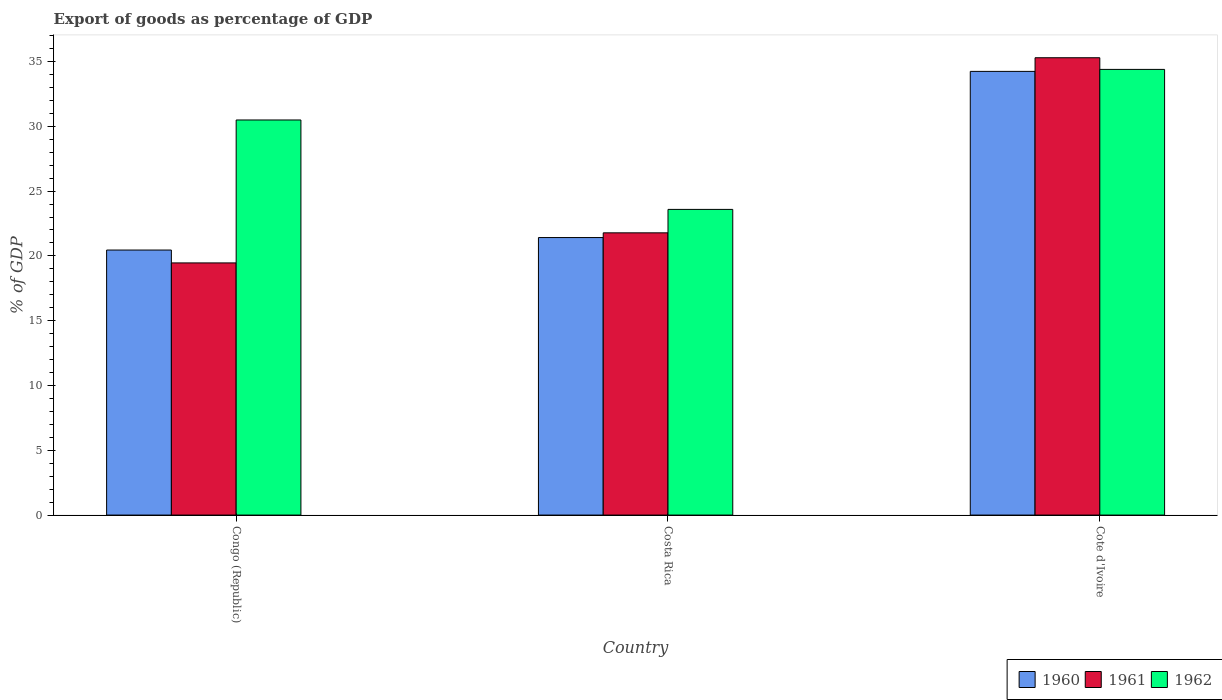How many different coloured bars are there?
Your answer should be very brief. 3. Are the number of bars per tick equal to the number of legend labels?
Offer a very short reply. Yes. How many bars are there on the 1st tick from the left?
Offer a very short reply. 3. How many bars are there on the 1st tick from the right?
Provide a short and direct response. 3. What is the label of the 2nd group of bars from the left?
Your answer should be compact. Costa Rica. What is the export of goods as percentage of GDP in 1961 in Cote d'Ivoire?
Provide a short and direct response. 35.29. Across all countries, what is the maximum export of goods as percentage of GDP in 1960?
Keep it short and to the point. 34.24. Across all countries, what is the minimum export of goods as percentage of GDP in 1961?
Offer a very short reply. 19.46. In which country was the export of goods as percentage of GDP in 1962 maximum?
Offer a terse response. Cote d'Ivoire. In which country was the export of goods as percentage of GDP in 1960 minimum?
Offer a terse response. Congo (Republic). What is the total export of goods as percentage of GDP in 1961 in the graph?
Make the answer very short. 76.53. What is the difference between the export of goods as percentage of GDP in 1961 in Congo (Republic) and that in Costa Rica?
Keep it short and to the point. -2.32. What is the difference between the export of goods as percentage of GDP in 1961 in Costa Rica and the export of goods as percentage of GDP in 1962 in Congo (Republic)?
Provide a short and direct response. -8.71. What is the average export of goods as percentage of GDP in 1961 per country?
Make the answer very short. 25.51. What is the difference between the export of goods as percentage of GDP of/in 1960 and export of goods as percentage of GDP of/in 1962 in Costa Rica?
Ensure brevity in your answer.  -2.17. What is the ratio of the export of goods as percentage of GDP in 1962 in Costa Rica to that in Cote d'Ivoire?
Your answer should be very brief. 0.69. What is the difference between the highest and the second highest export of goods as percentage of GDP in 1960?
Your answer should be very brief. 13.79. What is the difference between the highest and the lowest export of goods as percentage of GDP in 1960?
Offer a very short reply. 13.79. In how many countries, is the export of goods as percentage of GDP in 1961 greater than the average export of goods as percentage of GDP in 1961 taken over all countries?
Your response must be concise. 1. Is the sum of the export of goods as percentage of GDP in 1962 in Costa Rica and Cote d'Ivoire greater than the maximum export of goods as percentage of GDP in 1961 across all countries?
Provide a short and direct response. Yes. What does the 1st bar from the left in Cote d'Ivoire represents?
Give a very brief answer. 1960. What does the 2nd bar from the right in Costa Rica represents?
Provide a succinct answer. 1961. Are all the bars in the graph horizontal?
Offer a terse response. No. How many countries are there in the graph?
Your answer should be compact. 3. What is the difference between two consecutive major ticks on the Y-axis?
Your answer should be compact. 5. Are the values on the major ticks of Y-axis written in scientific E-notation?
Offer a very short reply. No. Does the graph contain any zero values?
Provide a short and direct response. No. Where does the legend appear in the graph?
Keep it short and to the point. Bottom right. What is the title of the graph?
Keep it short and to the point. Export of goods as percentage of GDP. Does "1966" appear as one of the legend labels in the graph?
Offer a very short reply. No. What is the label or title of the Y-axis?
Your answer should be very brief. % of GDP. What is the % of GDP of 1960 in Congo (Republic)?
Keep it short and to the point. 20.45. What is the % of GDP of 1961 in Congo (Republic)?
Give a very brief answer. 19.46. What is the % of GDP of 1962 in Congo (Republic)?
Ensure brevity in your answer.  30.49. What is the % of GDP of 1960 in Costa Rica?
Provide a short and direct response. 21.42. What is the % of GDP of 1961 in Costa Rica?
Ensure brevity in your answer.  21.78. What is the % of GDP in 1962 in Costa Rica?
Offer a very short reply. 23.59. What is the % of GDP in 1960 in Cote d'Ivoire?
Your response must be concise. 34.24. What is the % of GDP in 1961 in Cote d'Ivoire?
Your answer should be very brief. 35.29. What is the % of GDP of 1962 in Cote d'Ivoire?
Your answer should be compact. 34.39. Across all countries, what is the maximum % of GDP in 1960?
Keep it short and to the point. 34.24. Across all countries, what is the maximum % of GDP of 1961?
Offer a terse response. 35.29. Across all countries, what is the maximum % of GDP in 1962?
Your answer should be very brief. 34.39. Across all countries, what is the minimum % of GDP in 1960?
Your answer should be compact. 20.45. Across all countries, what is the minimum % of GDP of 1961?
Your answer should be very brief. 19.46. Across all countries, what is the minimum % of GDP of 1962?
Provide a short and direct response. 23.59. What is the total % of GDP in 1960 in the graph?
Give a very brief answer. 76.11. What is the total % of GDP of 1961 in the graph?
Your answer should be compact. 76.53. What is the total % of GDP in 1962 in the graph?
Offer a very short reply. 88.47. What is the difference between the % of GDP in 1960 in Congo (Republic) and that in Costa Rica?
Make the answer very short. -0.96. What is the difference between the % of GDP in 1961 in Congo (Republic) and that in Costa Rica?
Give a very brief answer. -2.32. What is the difference between the % of GDP in 1962 in Congo (Republic) and that in Costa Rica?
Offer a terse response. 6.9. What is the difference between the % of GDP in 1960 in Congo (Republic) and that in Cote d'Ivoire?
Your response must be concise. -13.79. What is the difference between the % of GDP in 1961 in Congo (Republic) and that in Cote d'Ivoire?
Your response must be concise. -15.83. What is the difference between the % of GDP in 1962 in Congo (Republic) and that in Cote d'Ivoire?
Give a very brief answer. -3.9. What is the difference between the % of GDP in 1960 in Costa Rica and that in Cote d'Ivoire?
Keep it short and to the point. -12.82. What is the difference between the % of GDP of 1961 in Costa Rica and that in Cote d'Ivoire?
Provide a succinct answer. -13.51. What is the difference between the % of GDP in 1962 in Costa Rica and that in Cote d'Ivoire?
Your answer should be very brief. -10.8. What is the difference between the % of GDP in 1960 in Congo (Republic) and the % of GDP in 1961 in Costa Rica?
Your answer should be very brief. -1.33. What is the difference between the % of GDP in 1960 in Congo (Republic) and the % of GDP in 1962 in Costa Rica?
Offer a terse response. -3.14. What is the difference between the % of GDP of 1961 in Congo (Republic) and the % of GDP of 1962 in Costa Rica?
Your response must be concise. -4.13. What is the difference between the % of GDP in 1960 in Congo (Republic) and the % of GDP in 1961 in Cote d'Ivoire?
Make the answer very short. -14.84. What is the difference between the % of GDP of 1960 in Congo (Republic) and the % of GDP of 1962 in Cote d'Ivoire?
Provide a succinct answer. -13.94. What is the difference between the % of GDP of 1961 in Congo (Republic) and the % of GDP of 1962 in Cote d'Ivoire?
Keep it short and to the point. -14.93. What is the difference between the % of GDP in 1960 in Costa Rica and the % of GDP in 1961 in Cote d'Ivoire?
Offer a terse response. -13.88. What is the difference between the % of GDP of 1960 in Costa Rica and the % of GDP of 1962 in Cote d'Ivoire?
Your response must be concise. -12.98. What is the difference between the % of GDP of 1961 in Costa Rica and the % of GDP of 1962 in Cote d'Ivoire?
Your response must be concise. -12.61. What is the average % of GDP of 1960 per country?
Your response must be concise. 25.37. What is the average % of GDP of 1961 per country?
Keep it short and to the point. 25.51. What is the average % of GDP in 1962 per country?
Give a very brief answer. 29.49. What is the difference between the % of GDP of 1960 and % of GDP of 1961 in Congo (Republic)?
Keep it short and to the point. 0.99. What is the difference between the % of GDP of 1960 and % of GDP of 1962 in Congo (Republic)?
Your answer should be very brief. -10.04. What is the difference between the % of GDP in 1961 and % of GDP in 1962 in Congo (Republic)?
Offer a terse response. -11.03. What is the difference between the % of GDP in 1960 and % of GDP in 1961 in Costa Rica?
Keep it short and to the point. -0.36. What is the difference between the % of GDP in 1960 and % of GDP in 1962 in Costa Rica?
Provide a succinct answer. -2.17. What is the difference between the % of GDP in 1961 and % of GDP in 1962 in Costa Rica?
Your answer should be compact. -1.81. What is the difference between the % of GDP of 1960 and % of GDP of 1961 in Cote d'Ivoire?
Provide a succinct answer. -1.05. What is the difference between the % of GDP in 1960 and % of GDP in 1962 in Cote d'Ivoire?
Ensure brevity in your answer.  -0.15. What is the difference between the % of GDP of 1961 and % of GDP of 1962 in Cote d'Ivoire?
Keep it short and to the point. 0.9. What is the ratio of the % of GDP in 1960 in Congo (Republic) to that in Costa Rica?
Provide a succinct answer. 0.96. What is the ratio of the % of GDP of 1961 in Congo (Republic) to that in Costa Rica?
Offer a very short reply. 0.89. What is the ratio of the % of GDP of 1962 in Congo (Republic) to that in Costa Rica?
Your answer should be compact. 1.29. What is the ratio of the % of GDP of 1960 in Congo (Republic) to that in Cote d'Ivoire?
Your response must be concise. 0.6. What is the ratio of the % of GDP of 1961 in Congo (Republic) to that in Cote d'Ivoire?
Your answer should be very brief. 0.55. What is the ratio of the % of GDP in 1962 in Congo (Republic) to that in Cote d'Ivoire?
Your response must be concise. 0.89. What is the ratio of the % of GDP in 1960 in Costa Rica to that in Cote d'Ivoire?
Provide a succinct answer. 0.63. What is the ratio of the % of GDP of 1961 in Costa Rica to that in Cote d'Ivoire?
Provide a succinct answer. 0.62. What is the ratio of the % of GDP in 1962 in Costa Rica to that in Cote d'Ivoire?
Provide a short and direct response. 0.69. What is the difference between the highest and the second highest % of GDP in 1960?
Ensure brevity in your answer.  12.82. What is the difference between the highest and the second highest % of GDP in 1961?
Ensure brevity in your answer.  13.51. What is the difference between the highest and the second highest % of GDP in 1962?
Offer a very short reply. 3.9. What is the difference between the highest and the lowest % of GDP of 1960?
Provide a succinct answer. 13.79. What is the difference between the highest and the lowest % of GDP in 1961?
Provide a succinct answer. 15.83. What is the difference between the highest and the lowest % of GDP in 1962?
Keep it short and to the point. 10.8. 